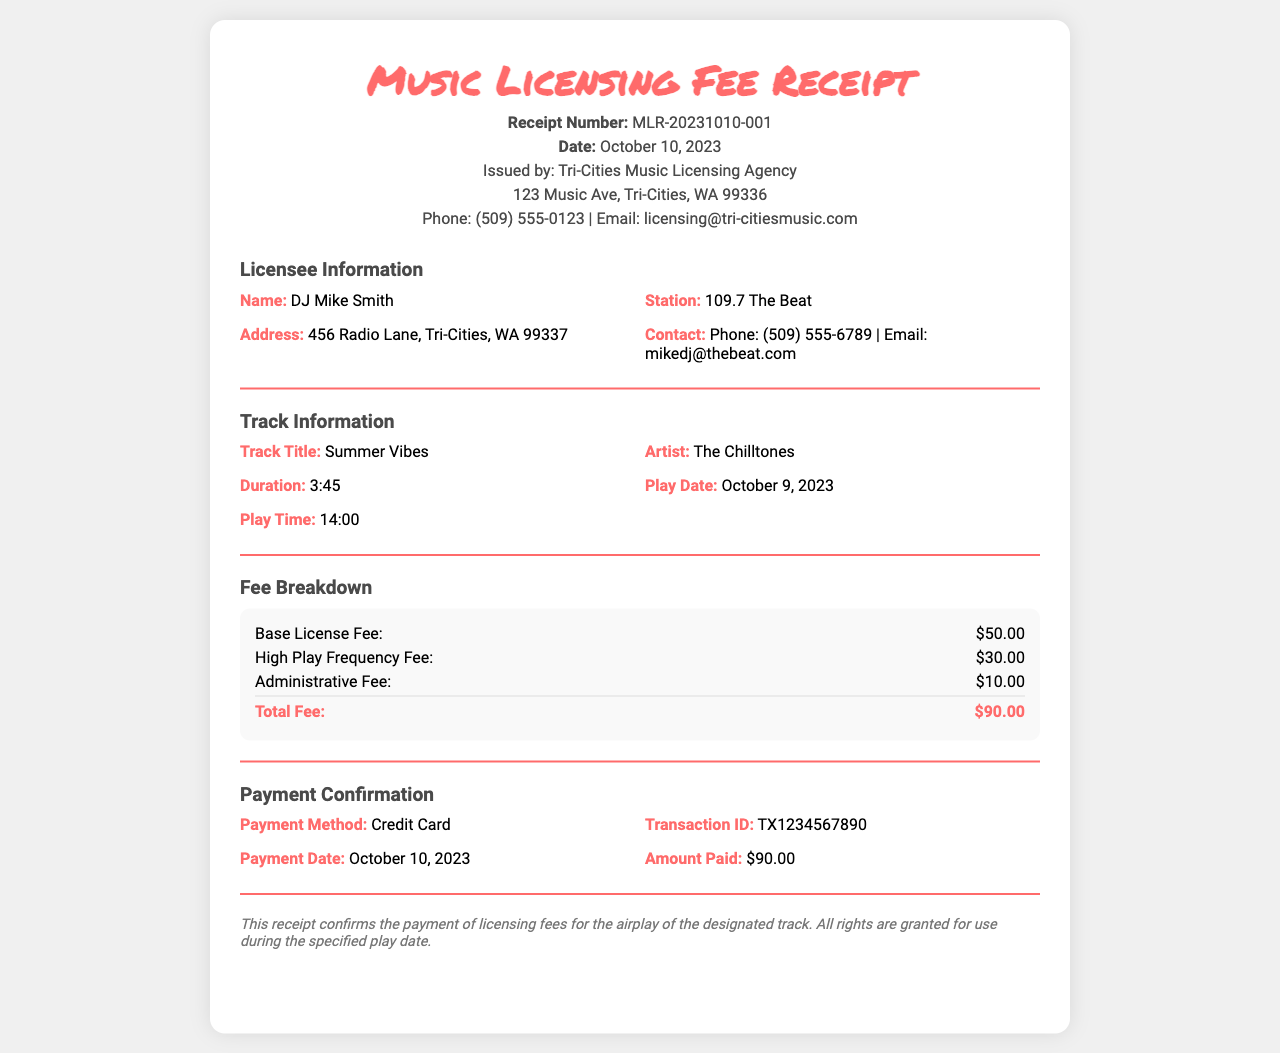What is the receipt number? The receipt number is specified in the header of the document under "Receipt Number."
Answer: MLR-20231010-001 Who is the artist of the track? The artist's name is mentioned in the "Track Information" section.
Answer: The Chilltones What is the total fee for the licensing? The total fee is stated in the "Fee Breakdown" section as the final sum.
Answer: $90.00 What date was the track played? The play date is provided in the "Track Information" section.
Answer: October 9, 2023 What is the payment method used? The payment method is detailed in the "Payment Confirmation" section.
Answer: Credit Card What is the duration of the track? The duration can be found in the "Track Information" section.
Answer: 3:45 How much was charged for the administrative fee? The administrative fee charge is listed in the "Fee Breakdown" section.
Answer: $10.00 What was the amount paid? The amount paid is included in the "Payment Confirmation" section.
Answer: $90.00 Who issued the receipt? The issuing agency is mentioned in the header of the document.
Answer: Tri-Cities Music Licensing Agency 